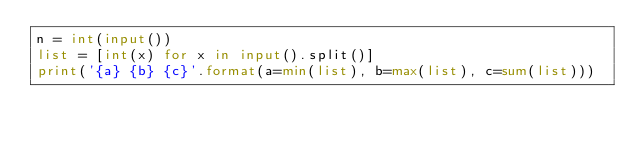<code> <loc_0><loc_0><loc_500><loc_500><_Python_>n = int(input())
list = [int(x) for x in input().split()]
print('{a} {b} {c}'.format(a=min(list), b=max(list), c=sum(list)))

</code> 